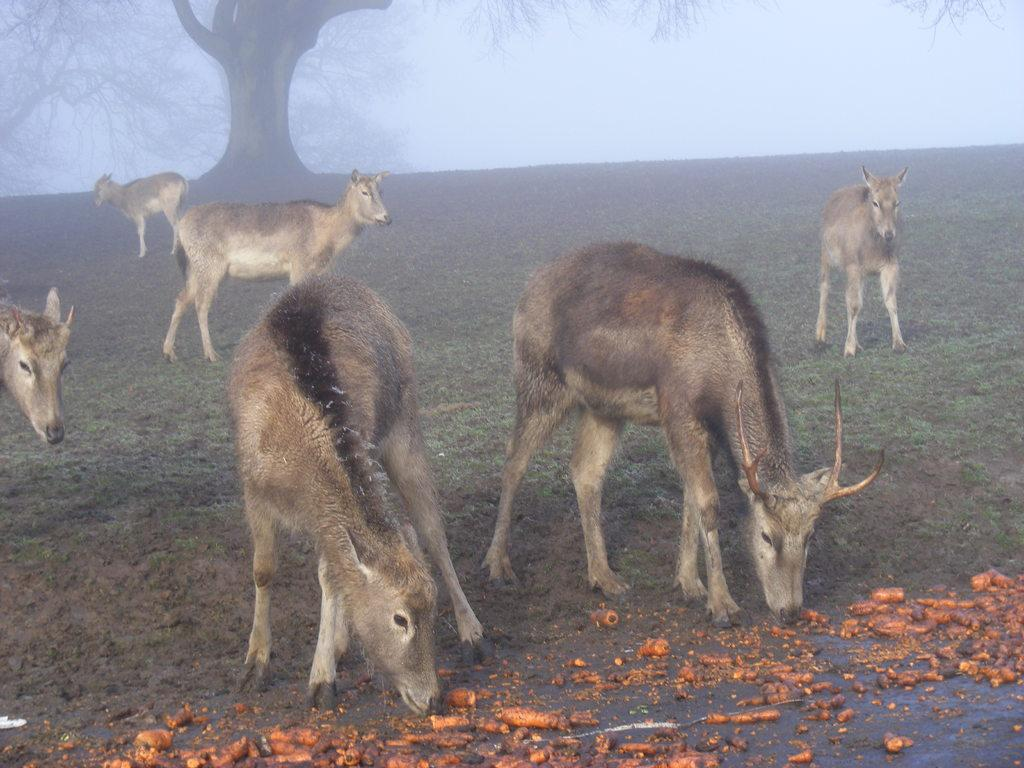What can be seen on the path in the image? There are animals on the path in the image. What is visible behind the animals? There are trees visible behind the animals. What is the condition of the background in the image? There is fog in the background of the image. What is present on the path in front of the animals? There are objects on the path in front of the animals. Who is the creator of the sofa in the image? There is no sofa present in the image. What reward can be seen for the animals in the image? There is no reward visible in the image; it only features animals, trees, fog, and objects on the path. 